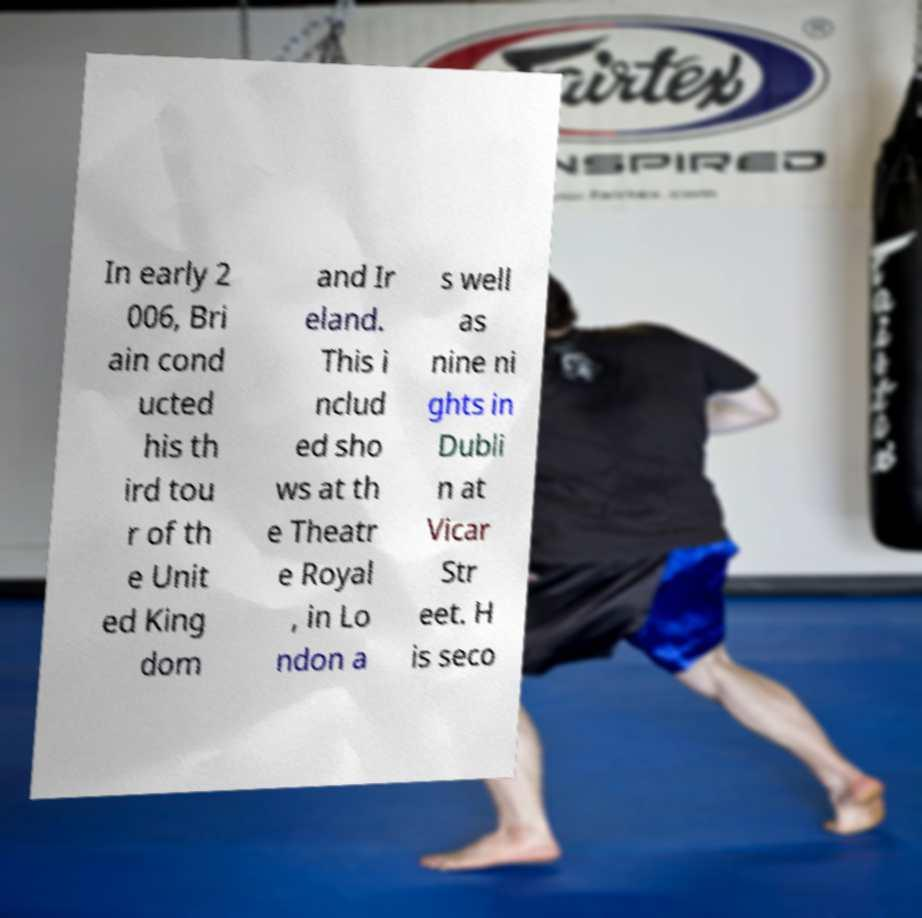What messages or text are displayed in this image? I need them in a readable, typed format. In early 2 006, Bri ain cond ucted his th ird tou r of th e Unit ed King dom and Ir eland. This i nclud ed sho ws at th e Theatr e Royal , in Lo ndon a s well as nine ni ghts in Dubli n at Vicar Str eet. H is seco 